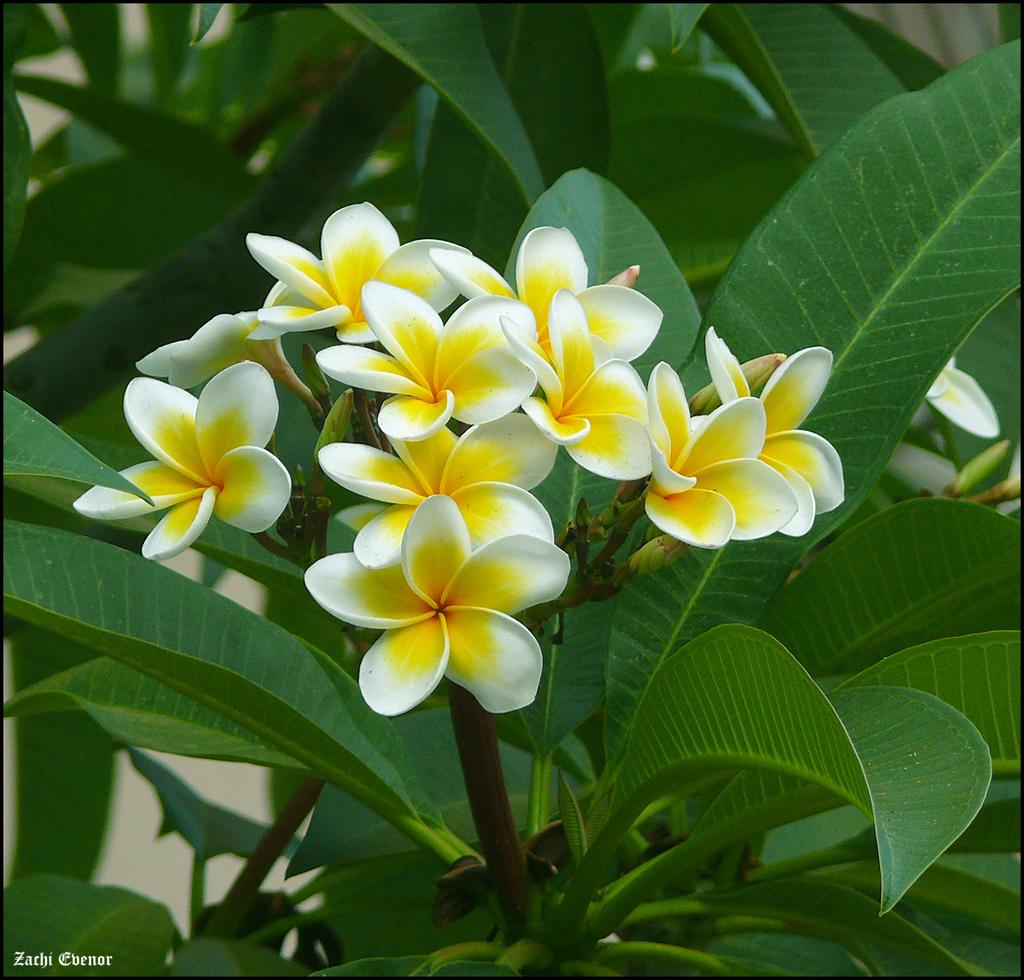What types of living organisms can be seen in the image? Plants and flowers are visible in the image. Can you describe the specific flora present in the image? There are flowers in the image, in addition to the plants. Is there any text present in the image? Yes, there is text on the bottom left corner of the image. What type of nose can be seen on the flowers in the image? There are no noses present on the flowers in the image, as flowers do not have noses. 